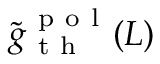<formula> <loc_0><loc_0><loc_500><loc_500>\tilde { g } _ { t h } ^ { p o l } ( L )</formula> 